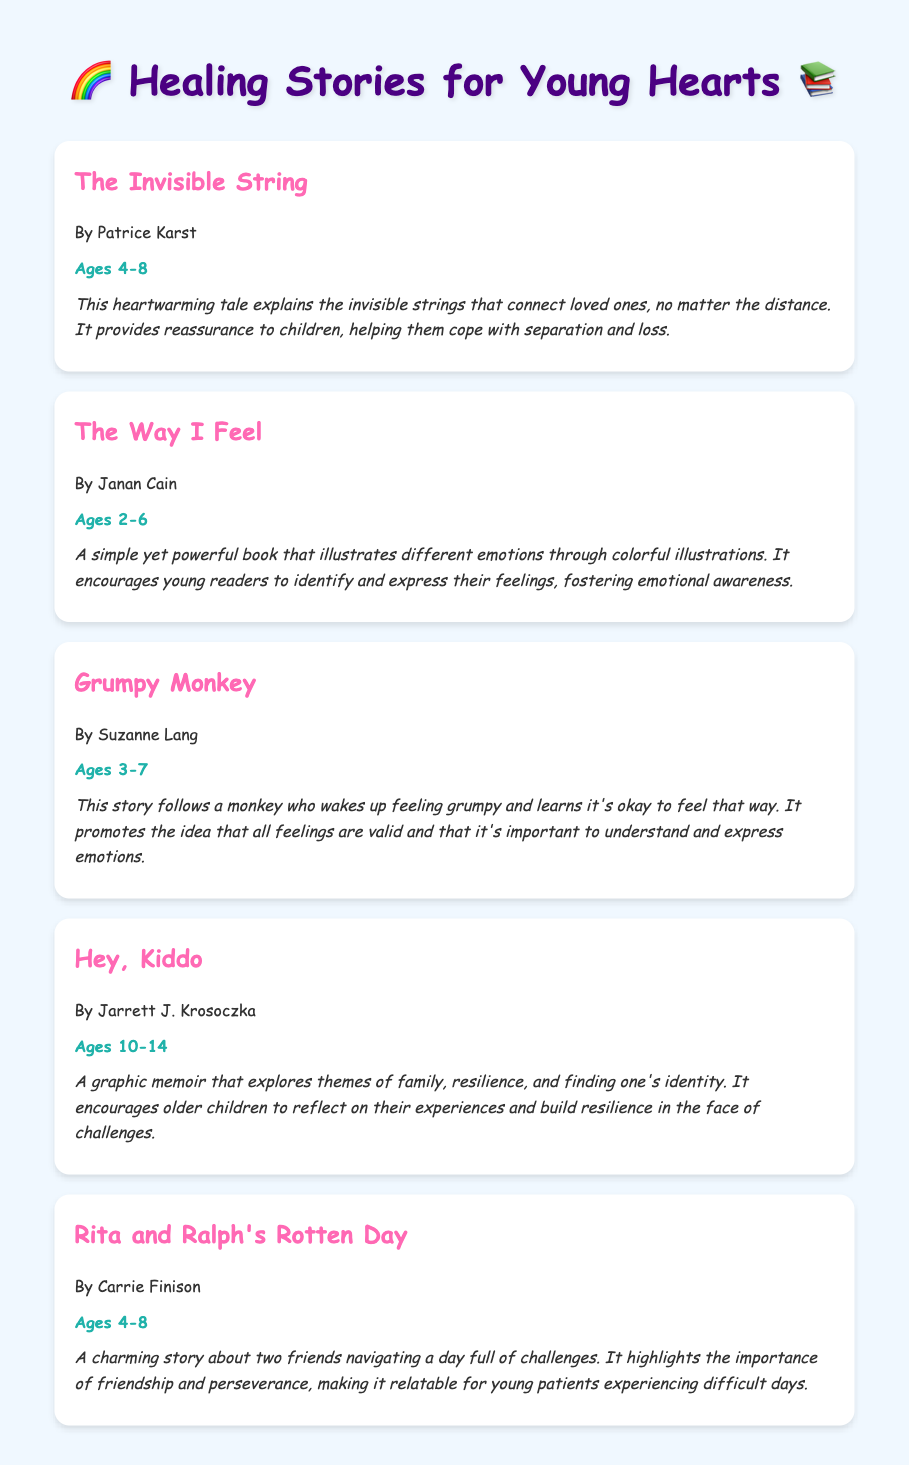What is the title of the first book? The first book listed in the document is titled "The Invisible String."
Answer: The Invisible String What age group is "Grumpy Monkey" intended for? The document specifies that "Grumpy Monkey" is appropriate for ages 3-7.
Answer: Ages 3-7 Who is the author of "Hey, Kiddo"? The author of "Hey, Kiddo" is Jarrett J. Krosoczka.
Answer: Jarrett J. Krosoczka What is the main theme of "The Way I Feel"? The main theme of "The Way I Feel" is to help young readers identify and express their feelings.
Answer: Emotional awareness How many books are listed in the document? There are a total of five books listed in the document.
Answer: Five Which book highlights the importance of friendship? "Rita and Ralph's Rotten Day" highlights the importance of friendship.
Answer: Rita and Ralph's Rotten Day What is the unique format of "Hey, Kiddo"? "Hey, Kiddo" is a graphic memoir.
Answer: Graphic memoir What type of stories does this document recommend? The document recommends healing stories for emotional resilience.
Answer: Healing stories 